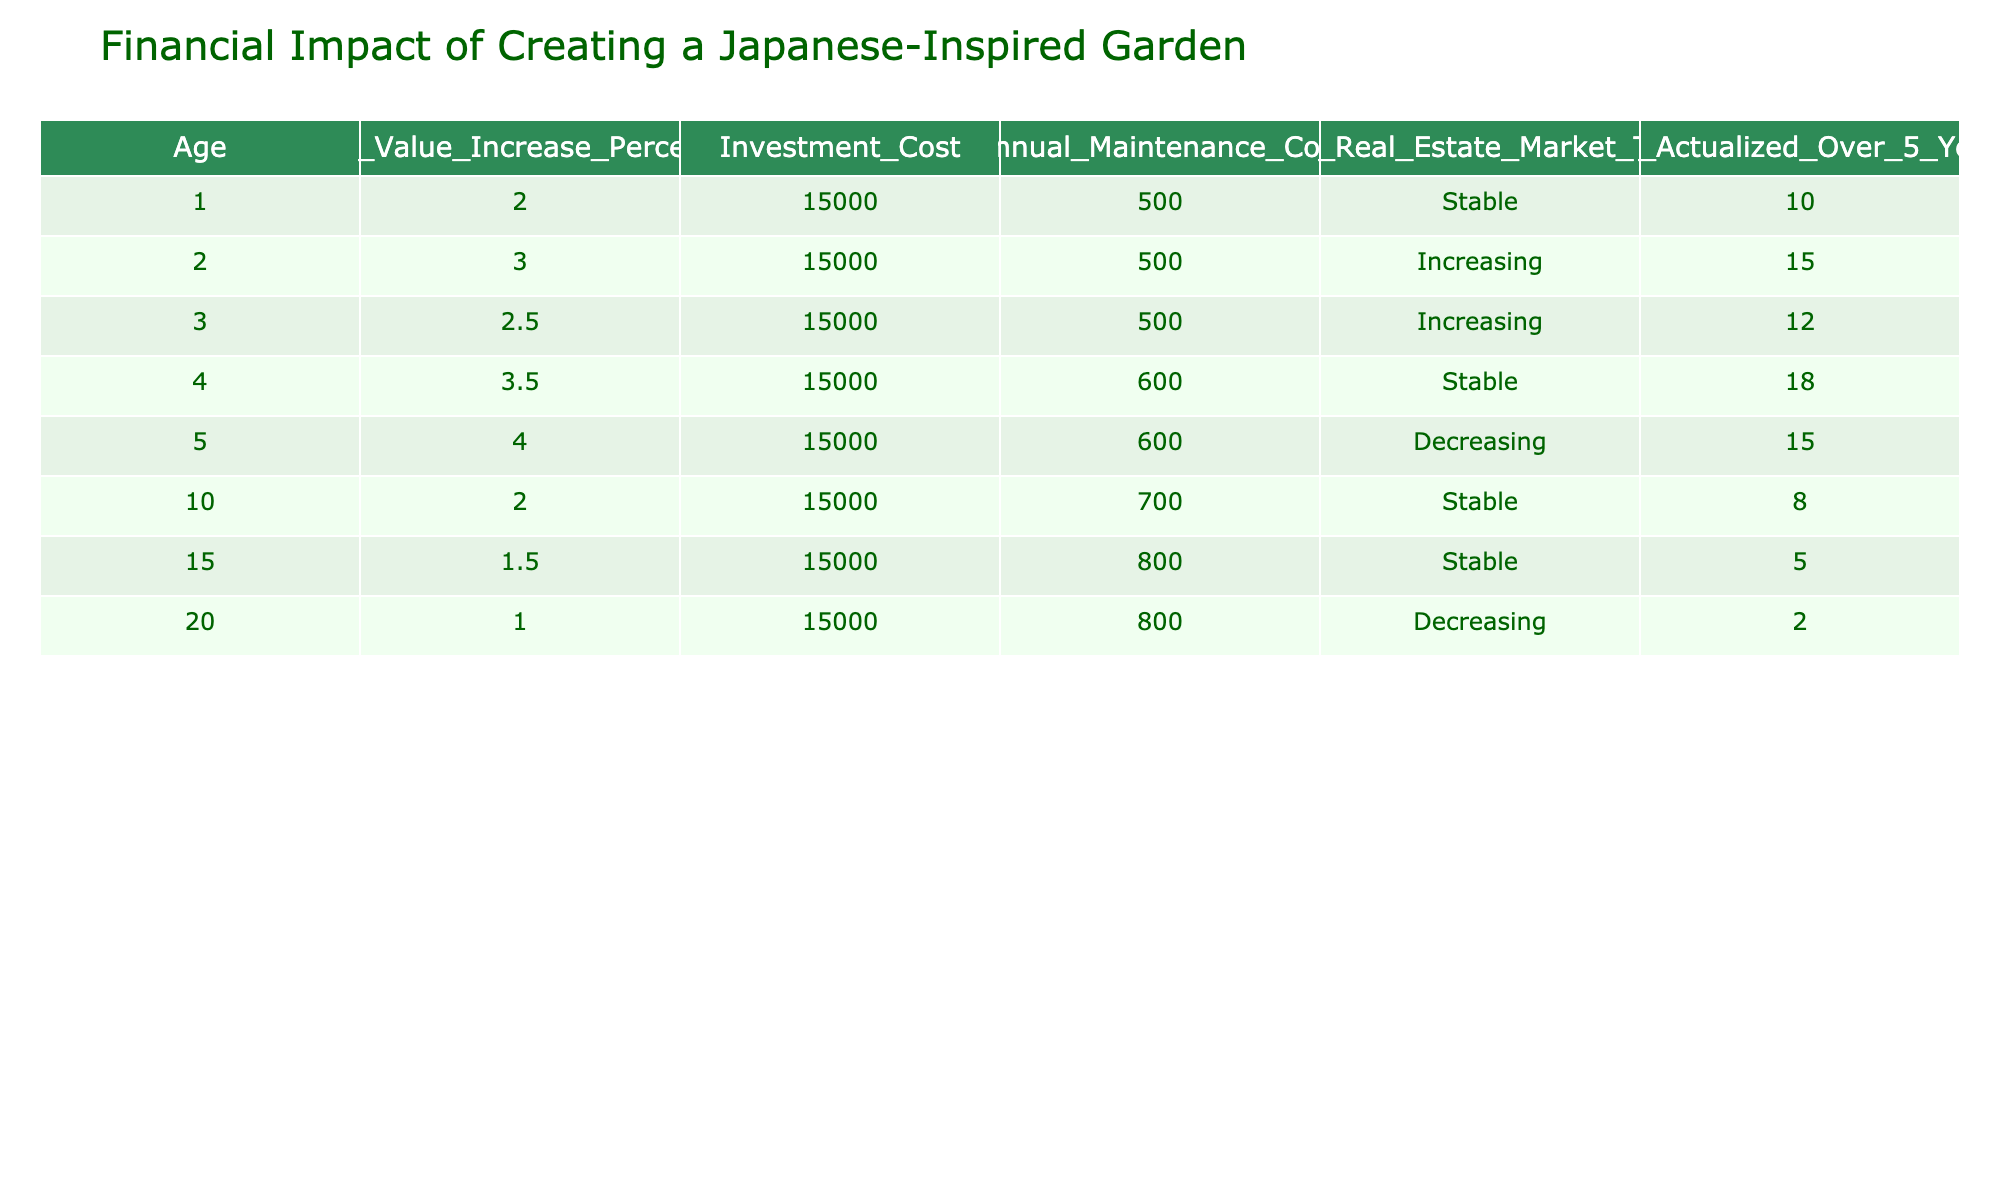What is the home value increase percentage after one year? In the first row of the table, the "Home_Value_Increase_Percentage" for age 1 is listed as 2.
Answer: 2 What is the annual maintenance cost for a garden investment after five years? In the fifth row, the "Annual_Maintenance_Cost" for age 5 is listed as 600.
Answer: 600 Is the local real estate market trend stable for the garden investment at age three? In the third row, the "Local_Real_Estate_Market_Trend" indicates "Increasing," so it is not stable.
Answer: No What is the total return on investment actualized over five years for investments with a decreasing market trend? For ages 5 and 20, the "ROI_Actualized_Over_5_Years" are 15 and 2 respectively. The total return is 15 + 2 = 17.
Answer: 17 Which age group shows the highest annual maintenance cost, and what is that cost? The highest maintenance cost is found in age 15, where the cost is 800.
Answer: 800 Is it true that the investment cost remains constant across all age groups? The "Investment_Cost" column is consistently at 15000 for all ages in the table.
Answer: Yes What is the average home value increase percentage for age groups under 10? The home value increase percentages for ages 1, 2, 3, 4, and 5 are 2, 3, 2.5, 3.5, and 4 respectively. The sum is 2 + 3 + 2.5 + 3.5 + 4 = 15, and there are 5 values. The average is 15 / 5 = 3.
Answer: 3 How does the ROI actualized five years change from age 1 to age 5? The ROI for age 1 is 10, and for age 5, it is 15. The difference is 15 - 10 = 5, indicating an increase of 5 over that period.
Answer: Increase of 5 What is the difference in home value increase percentage between age 2 and age 4? Age 2 has an increase of 3 and age 4 has an increase of 3.5, resulting in a difference of 3.5 - 3 = 0.5.
Answer: 0.5 What is the overall trend for the local real estate market from age 1 to age 20? The trends are stable for ages 1, 4, 10, and 15; increasing for ages 2 and 3; and decreasing for ages 5 and 20. Considering this mix, the trend experiences both stability and decline over time.
Answer: Mixed trend 